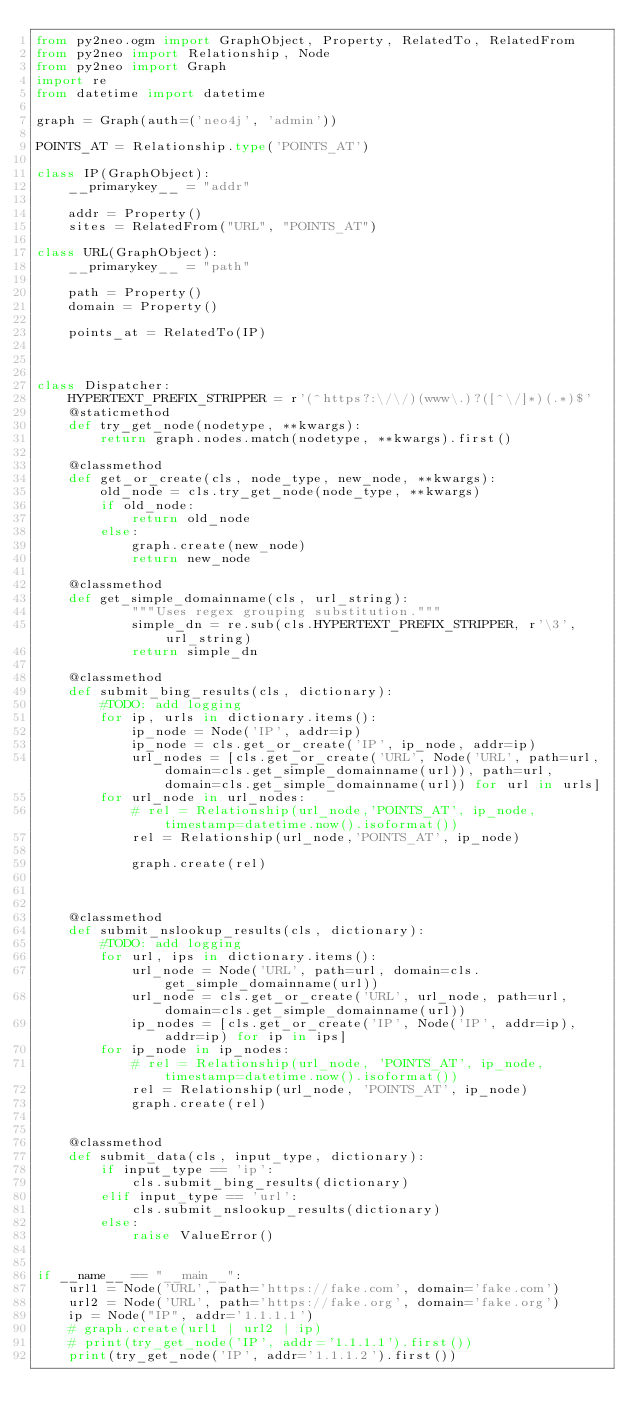<code> <loc_0><loc_0><loc_500><loc_500><_Python_>from py2neo.ogm import GraphObject, Property, RelatedTo, RelatedFrom
from py2neo import Relationship, Node
from py2neo import Graph
import re
from datetime import datetime

graph = Graph(auth=('neo4j', 'admin'))

POINTS_AT = Relationship.type('POINTS_AT')

class IP(GraphObject):
    __primarykey__ = "addr"

    addr = Property()
    sites = RelatedFrom("URL", "POINTS_AT")

class URL(GraphObject):
    __primarykey__ = "path"

    path = Property()
    domain = Property()

    points_at = RelatedTo(IP)



class Dispatcher:
    HYPERTEXT_PREFIX_STRIPPER = r'(^https?:\/\/)(www\.)?([^\/]*)(.*)$'
    @staticmethod
    def try_get_node(nodetype, **kwargs):
        return graph.nodes.match(nodetype, **kwargs).first()

    @classmethod
    def get_or_create(cls, node_type, new_node, **kwargs):
        old_node = cls.try_get_node(node_type, **kwargs)
        if old_node:
            return old_node
        else:
            graph.create(new_node)
            return new_node
    
    @classmethod
    def get_simple_domainname(cls, url_string):
            """Uses regex grouping substitution."""    
            simple_dn = re.sub(cls.HYPERTEXT_PREFIX_STRIPPER, r'\3', url_string)
            return simple_dn

    @classmethod
    def submit_bing_results(cls, dictionary):
        #TODO: add logging
        for ip, urls in dictionary.items():
            ip_node = Node('IP', addr=ip)
            ip_node = cls.get_or_create('IP', ip_node, addr=ip)
            url_nodes = [cls.get_or_create('URL', Node('URL', path=url, domain=cls.get_simple_domainname(url)), path=url, domain=cls.get_simple_domainname(url)) for url in urls]
        for url_node in url_nodes:
            # rel = Relationship(url_node,'POINTS_AT', ip_node, timestamp=datetime.now().isoformat())
            rel = Relationship(url_node,'POINTS_AT', ip_node)
            
            graph.create(rel)
            


    @classmethod
    def submit_nslookup_results(cls, dictionary):
        #TODO: add logging
        for url, ips in dictionary.items():
            url_node = Node('URL', path=url, domain=cls.get_simple_domainname(url))
            url_node = cls.get_or_create('URL', url_node, path=url, domain=cls.get_simple_domainname(url))
            ip_nodes = [cls.get_or_create('IP', Node('IP', addr=ip), addr=ip) for ip in ips]
        for ip_node in ip_nodes:
            # rel = Relationship(url_node, 'POINTS_AT', ip_node, timestamp=datetime.now().isoformat())
            rel = Relationship(url_node, 'POINTS_AT', ip_node)
            graph.create(rel)


    @classmethod
    def submit_data(cls, input_type, dictionary):
        if input_type == 'ip':
            cls.submit_bing_results(dictionary)
        elif input_type == 'url':
            cls.submit_nslookup_results(dictionary)
        else: 
            raise ValueError()


if __name__ == "__main__":
    url1 = Node('URL', path='https://fake.com', domain='fake.com')
    url2 = Node('URL', path='https://fake.org', domain='fake.org')
    ip = Node("IP", addr='1.1.1.1')
    # graph.create(url1 | url2 | ip)
    # print(try_get_node('IP', addr='1.1.1.1').first())
    print(try_get_node('IP', addr='1.1.1.2').first())</code> 